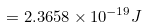<formula> <loc_0><loc_0><loc_500><loc_500>= 2 . 3 6 5 8 \times 1 0 ^ { - 1 9 } { J }</formula> 